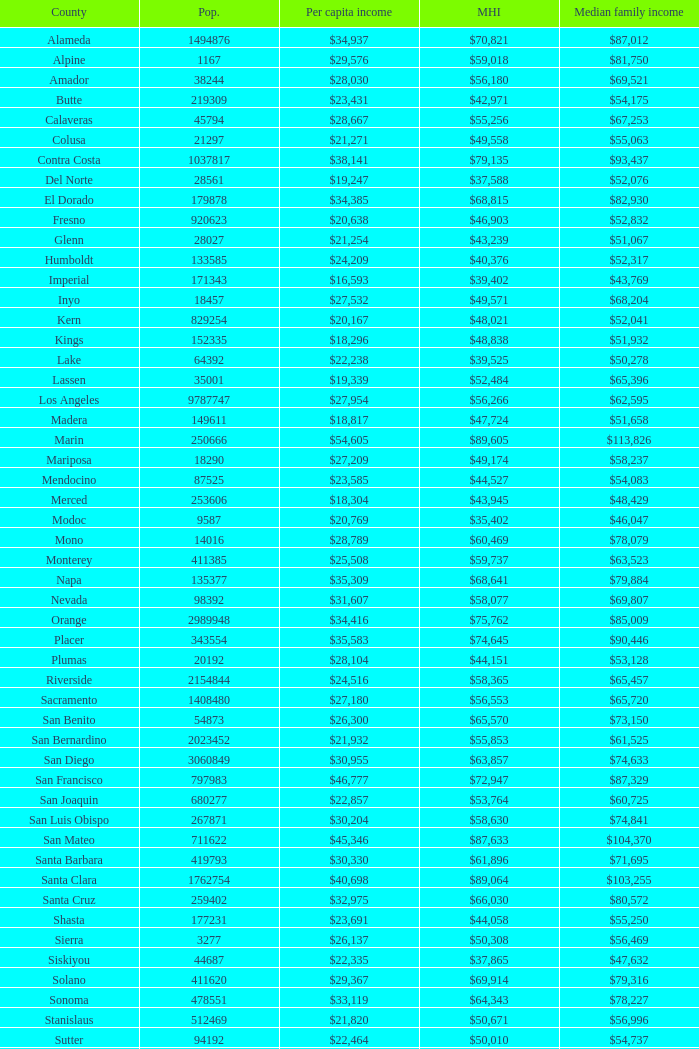Name the median family income for riverside $65,457. 